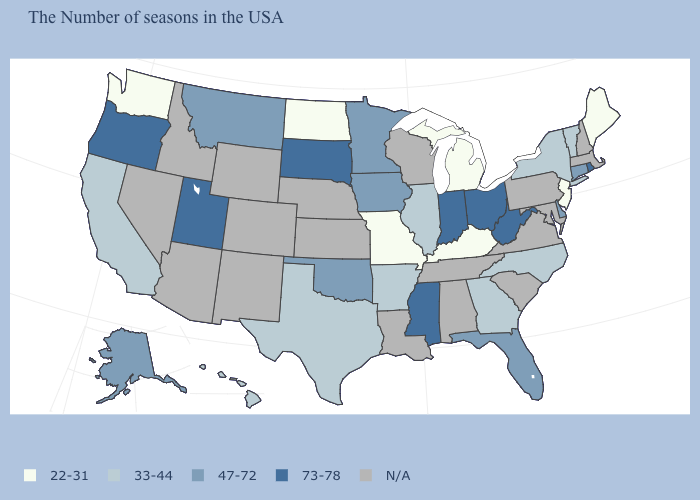Does Maine have the lowest value in the Northeast?
Give a very brief answer. Yes. Which states hav the highest value in the MidWest?
Be succinct. Ohio, Indiana, South Dakota. How many symbols are there in the legend?
Short answer required. 5. What is the value of Alaska?
Answer briefly. 47-72. What is the value of Oklahoma?
Give a very brief answer. 47-72. Name the states that have a value in the range N/A?
Answer briefly. Massachusetts, New Hampshire, Maryland, Pennsylvania, Virginia, South Carolina, Alabama, Tennessee, Wisconsin, Louisiana, Kansas, Nebraska, Wyoming, Colorado, New Mexico, Arizona, Idaho, Nevada. What is the highest value in the USA?
Keep it brief. 73-78. Name the states that have a value in the range 33-44?
Give a very brief answer. Vermont, New York, North Carolina, Georgia, Illinois, Arkansas, Texas, California, Hawaii. How many symbols are there in the legend?
Concise answer only. 5. What is the lowest value in the USA?
Keep it brief. 22-31. How many symbols are there in the legend?
Quick response, please. 5. What is the value of Iowa?
Give a very brief answer. 47-72. What is the highest value in the Northeast ?
Be succinct. 73-78. 